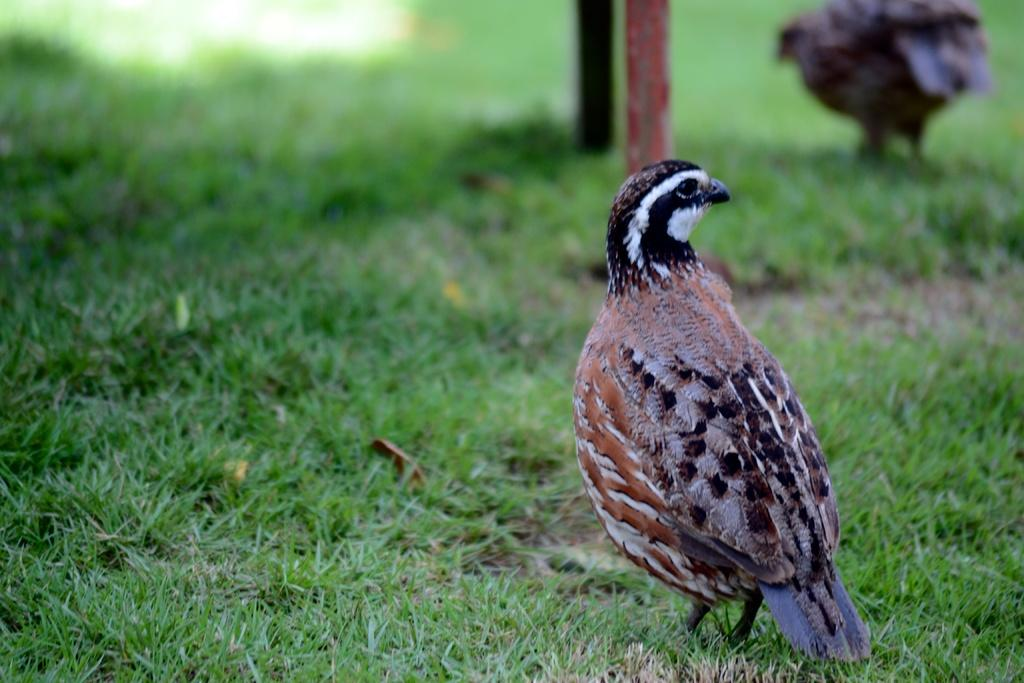What type of bird is in the image? There is a partridge bird in the image. Where is the partridge bird located? The partridge bird is standing on the grass. What can be seen at the top of the image? There are poles visible at the top of the image. Are there any other birds in the image besides the partridge bird? Yes, there is another bird in the image. What type of snow can be seen falling in the image? There is no snow present in the image; it features a partridge bird standing on the grass with poles visible at the top. 